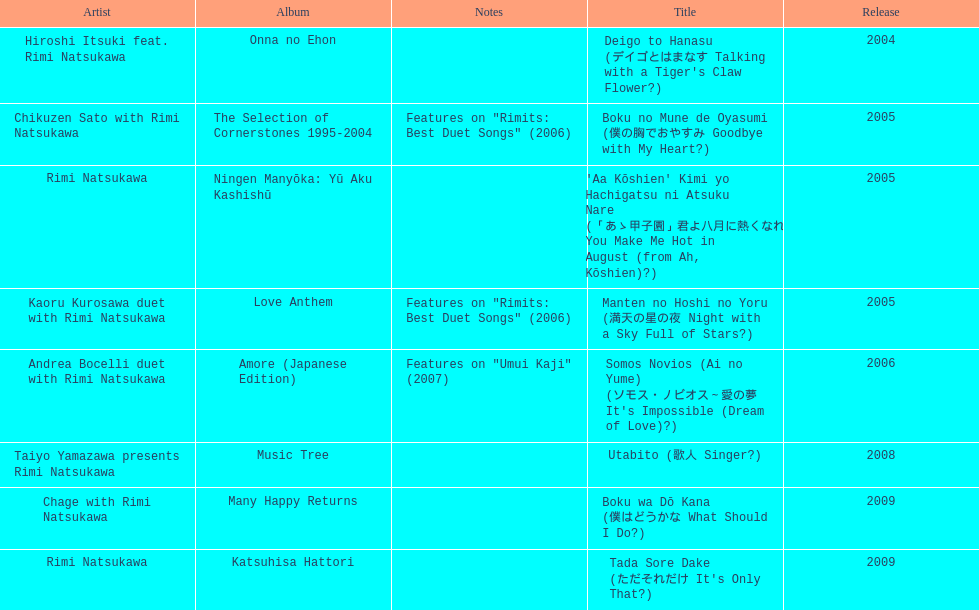What is the number of albums released with the artist rimi natsukawa? 8. 